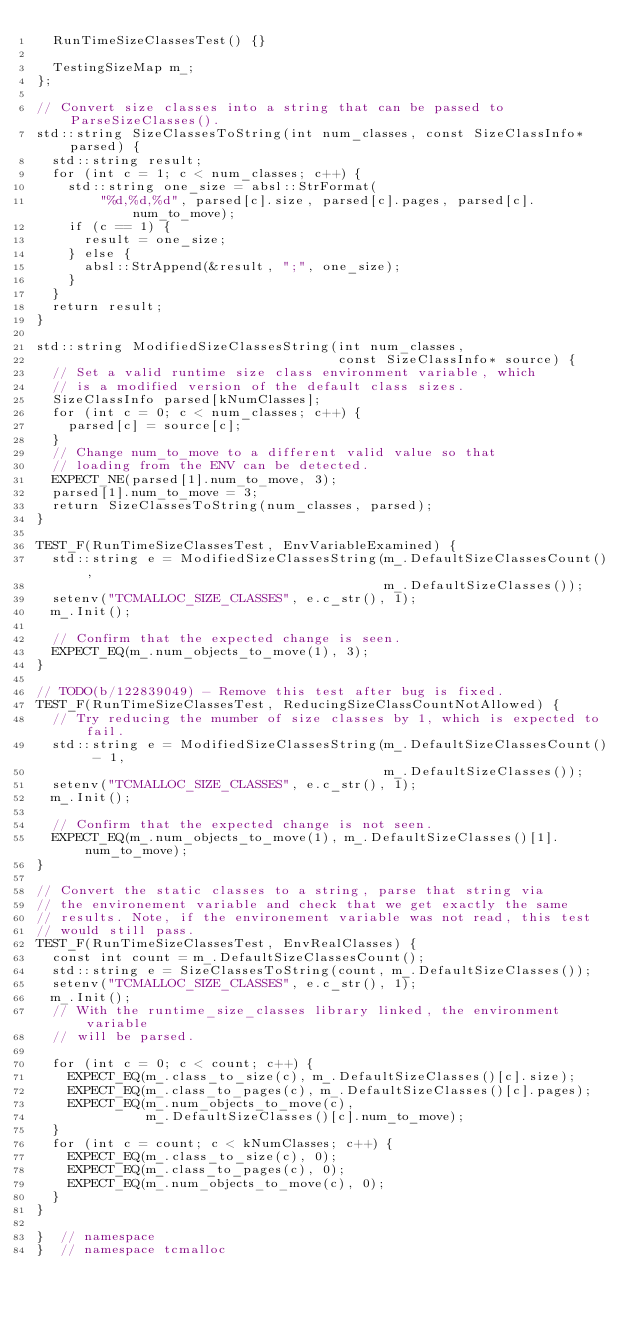<code> <loc_0><loc_0><loc_500><loc_500><_C++_>  RunTimeSizeClassesTest() {}

  TestingSizeMap m_;
};

// Convert size classes into a string that can be passed to ParseSizeClasses().
std::string SizeClassesToString(int num_classes, const SizeClassInfo* parsed) {
  std::string result;
  for (int c = 1; c < num_classes; c++) {
    std::string one_size = absl::StrFormat(
        "%d,%d,%d", parsed[c].size, parsed[c].pages, parsed[c].num_to_move);
    if (c == 1) {
      result = one_size;
    } else {
      absl::StrAppend(&result, ";", one_size);
    }
  }
  return result;
}

std::string ModifiedSizeClassesString(int num_classes,
                                      const SizeClassInfo* source) {
  // Set a valid runtime size class environment variable, which
  // is a modified version of the default class sizes.
  SizeClassInfo parsed[kNumClasses];
  for (int c = 0; c < num_classes; c++) {
    parsed[c] = source[c];
  }
  // Change num_to_move to a different valid value so that
  // loading from the ENV can be detected.
  EXPECT_NE(parsed[1].num_to_move, 3);
  parsed[1].num_to_move = 3;
  return SizeClassesToString(num_classes, parsed);
}

TEST_F(RunTimeSizeClassesTest, EnvVariableExamined) {
  std::string e = ModifiedSizeClassesString(m_.DefaultSizeClassesCount(),
                                            m_.DefaultSizeClasses());
  setenv("TCMALLOC_SIZE_CLASSES", e.c_str(), 1);
  m_.Init();

  // Confirm that the expected change is seen.
  EXPECT_EQ(m_.num_objects_to_move(1), 3);
}

// TODO(b/122839049) - Remove this test after bug is fixed.
TEST_F(RunTimeSizeClassesTest, ReducingSizeClassCountNotAllowed) {
  // Try reducing the mumber of size classes by 1, which is expected to fail.
  std::string e = ModifiedSizeClassesString(m_.DefaultSizeClassesCount() - 1,
                                            m_.DefaultSizeClasses());
  setenv("TCMALLOC_SIZE_CLASSES", e.c_str(), 1);
  m_.Init();

  // Confirm that the expected change is not seen.
  EXPECT_EQ(m_.num_objects_to_move(1), m_.DefaultSizeClasses()[1].num_to_move);
}

// Convert the static classes to a string, parse that string via
// the environement variable and check that we get exactly the same
// results. Note, if the environement variable was not read, this test
// would still pass.
TEST_F(RunTimeSizeClassesTest, EnvRealClasses) {
  const int count = m_.DefaultSizeClassesCount();
  std::string e = SizeClassesToString(count, m_.DefaultSizeClasses());
  setenv("TCMALLOC_SIZE_CLASSES", e.c_str(), 1);
  m_.Init();
  // With the runtime_size_classes library linked, the environment variable
  // will be parsed.

  for (int c = 0; c < count; c++) {
    EXPECT_EQ(m_.class_to_size(c), m_.DefaultSizeClasses()[c].size);
    EXPECT_EQ(m_.class_to_pages(c), m_.DefaultSizeClasses()[c].pages);
    EXPECT_EQ(m_.num_objects_to_move(c),
              m_.DefaultSizeClasses()[c].num_to_move);
  }
  for (int c = count; c < kNumClasses; c++) {
    EXPECT_EQ(m_.class_to_size(c), 0);
    EXPECT_EQ(m_.class_to_pages(c), 0);
    EXPECT_EQ(m_.num_objects_to_move(c), 0);
  }
}

}  // namespace
}  // namespace tcmalloc
</code> 